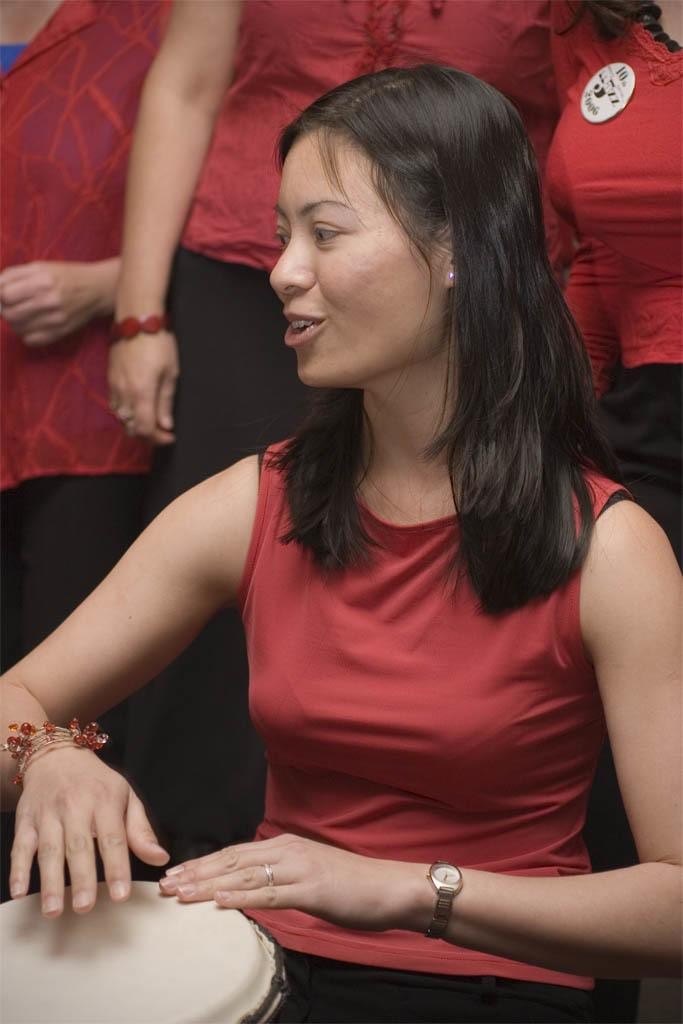Who is the main subject in the image? There is a woman in the image. What is the woman doing in the image? The woman is sitting and playing a drum. Are there any other people in the image? Yes, there are people behind the woman. What type of tub can be seen in the image? There is no tub present in the image. 